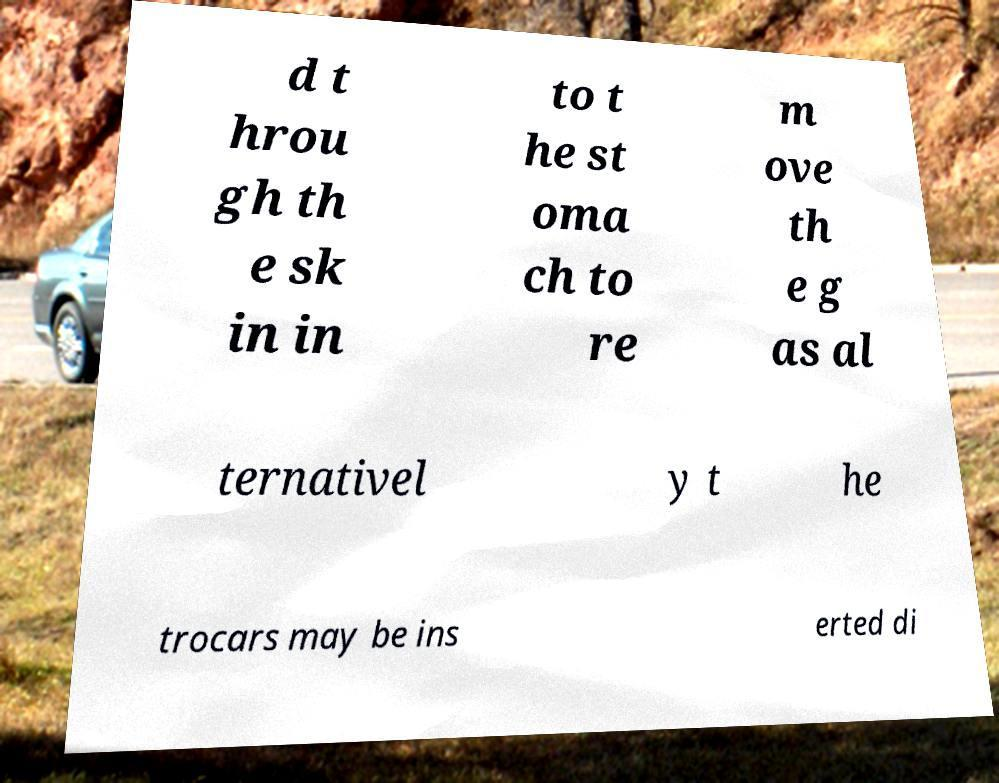There's text embedded in this image that I need extracted. Can you transcribe it verbatim? d t hrou gh th e sk in in to t he st oma ch to re m ove th e g as al ternativel y t he trocars may be ins erted di 